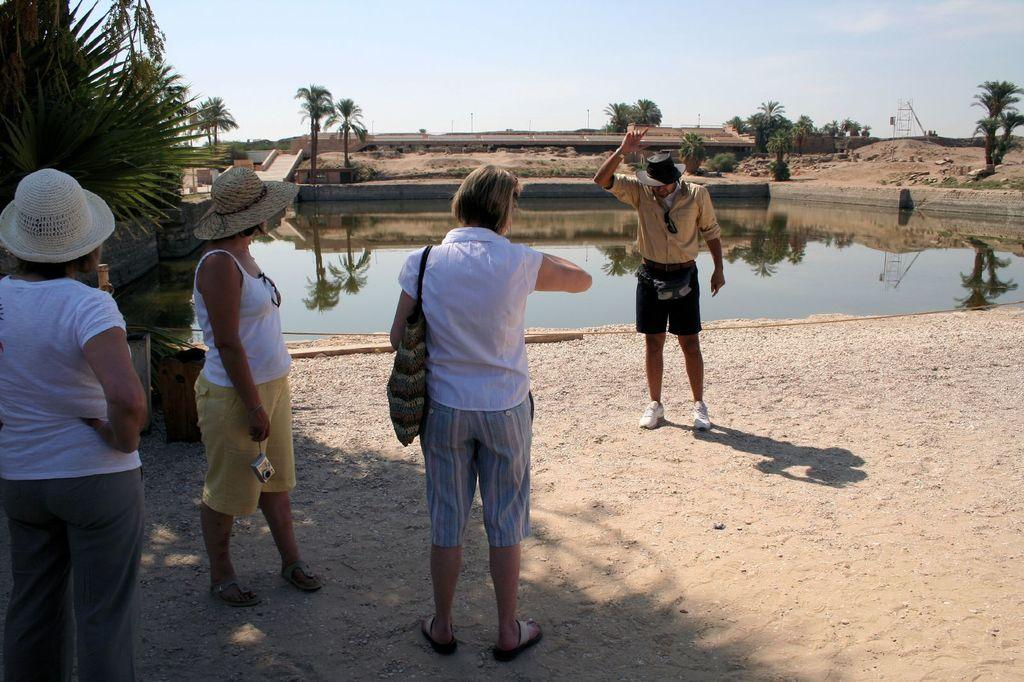How many persons are in the foreground of the image? There are four persons standing in the foreground of the image. Can you describe the attire of the persons in the image? Some of the persons are wearing hats. What can be seen in the background of the image? There are trees, a pond, stairs, poles, and the sky visible in the background of the image. What type of stone can be seen in the image? There is no stone present in the image. Are there any pets visible in the image? There is no mention of pets in the image; it features four persons standing in the foreground and various elements in the background. 